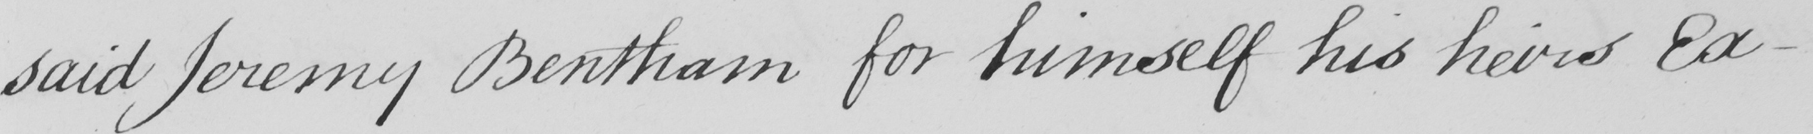What is written in this line of handwriting? said Jeremy Bentham for himself his heirs Ex- 